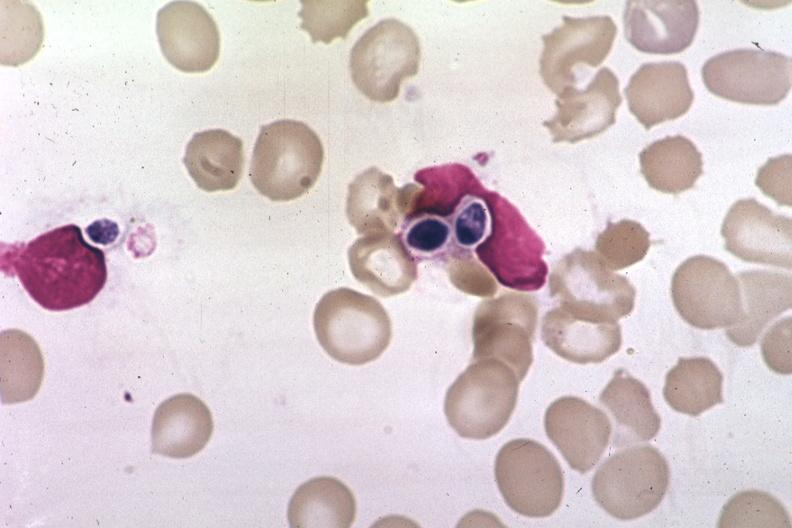s blood present?
Answer the question using a single word or phrase. Yes 